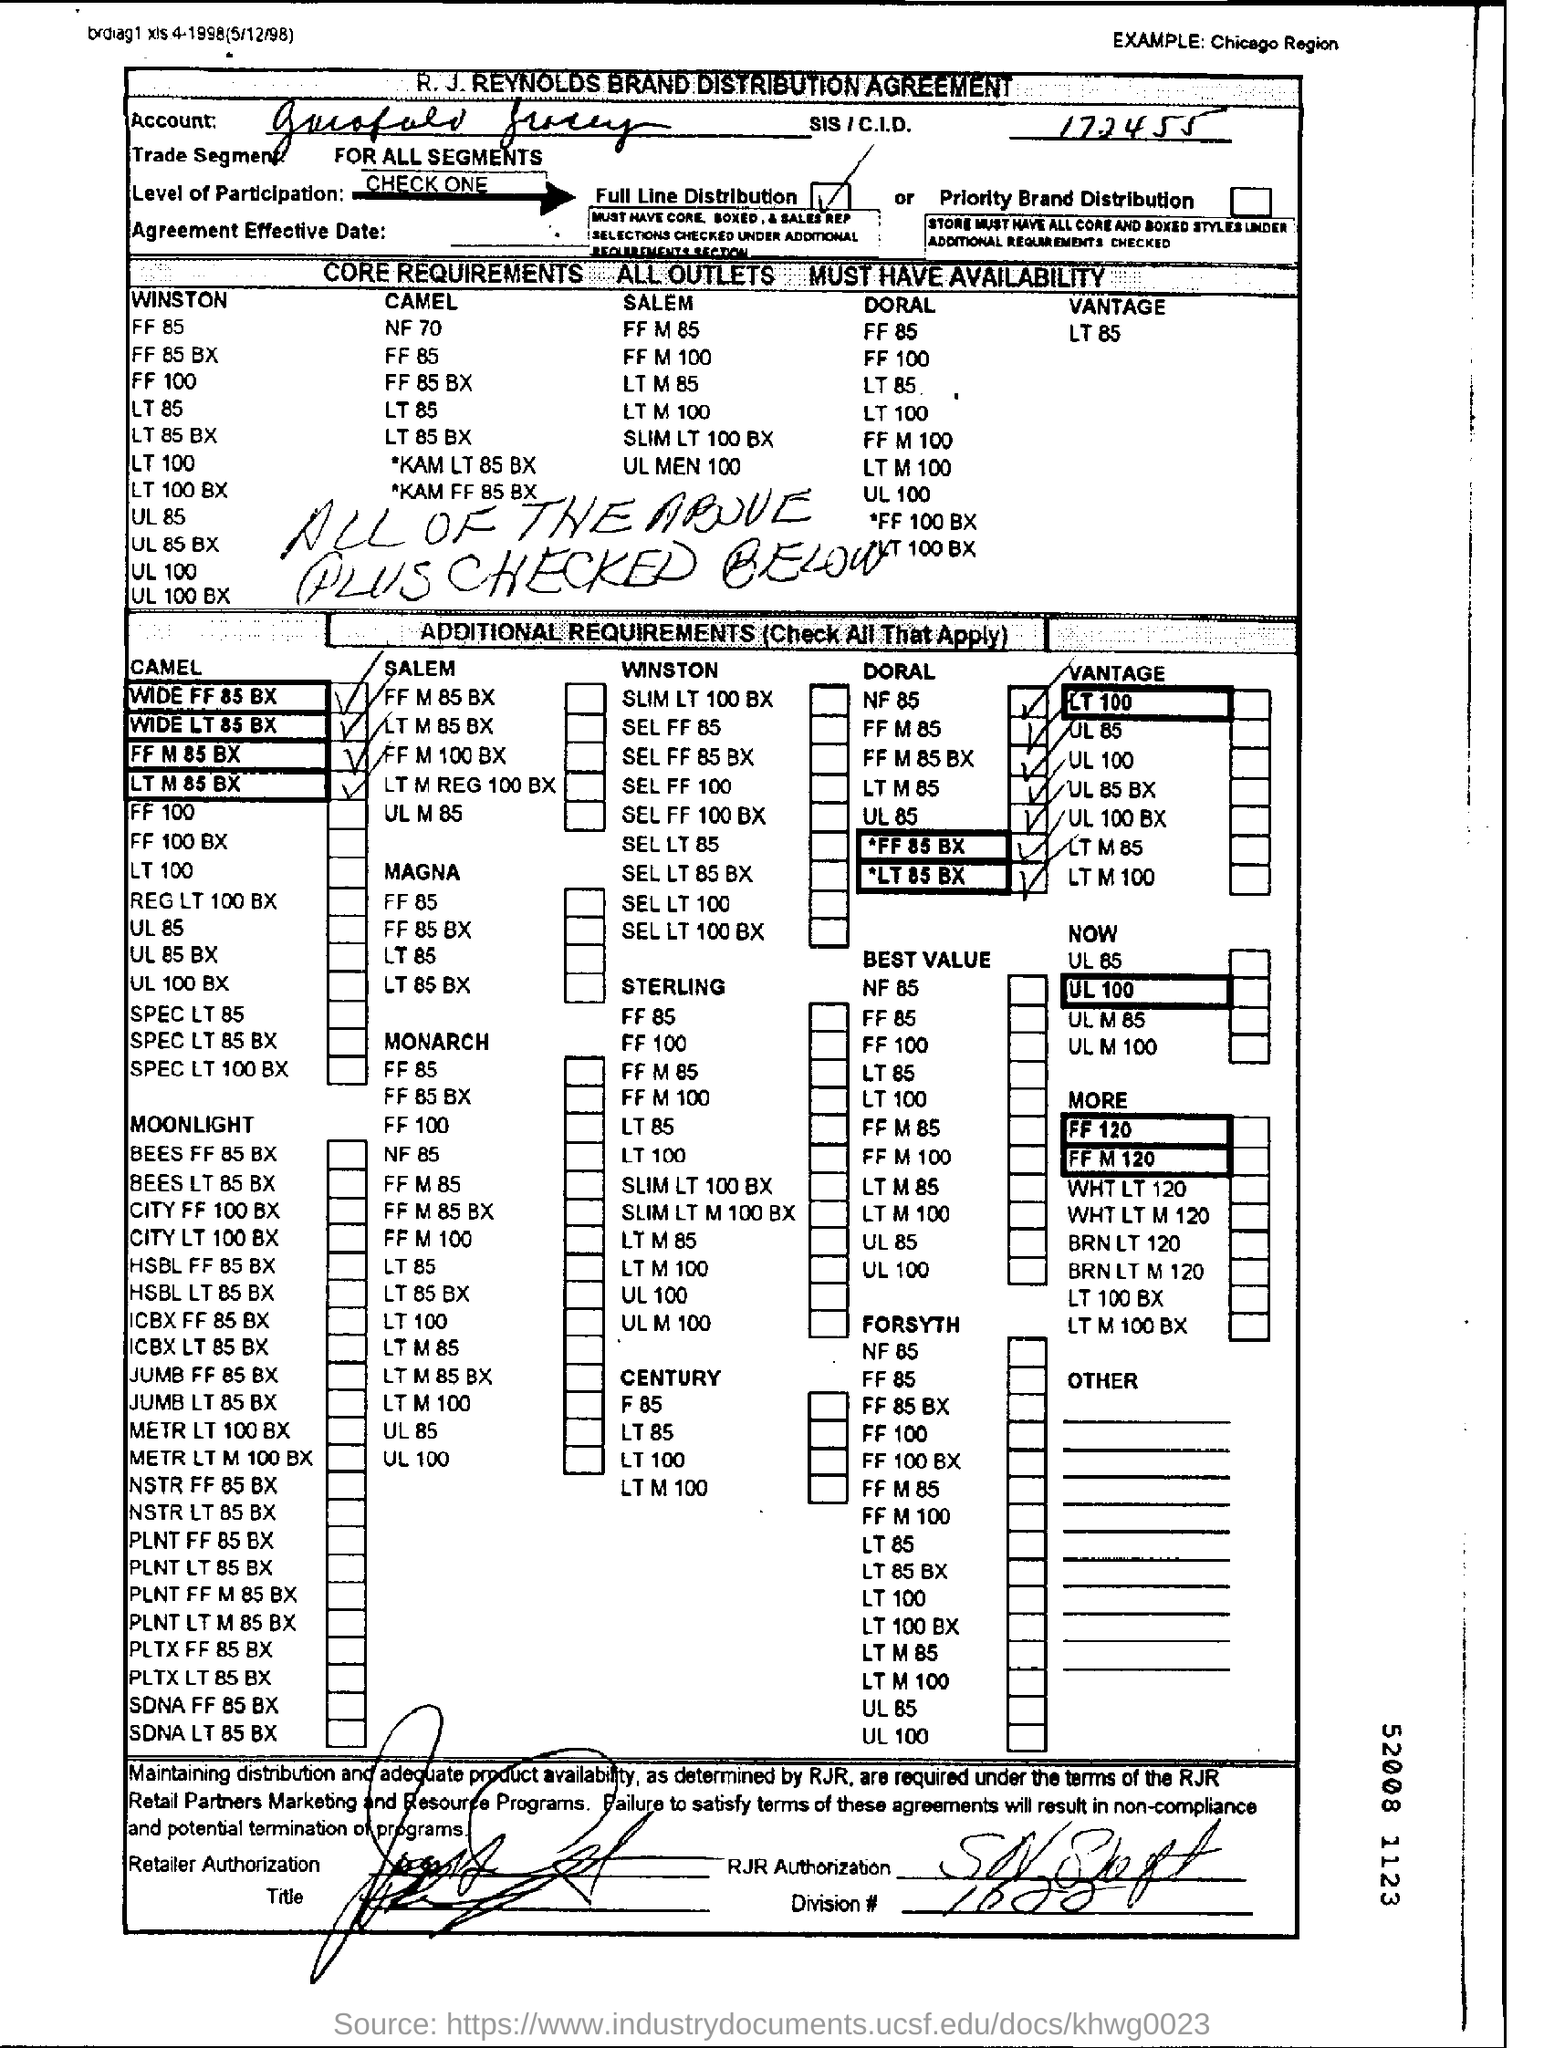What is the text wtitten on the top right corner?
Offer a terse response. EXAMPLE:Chicago Region. What is the name of the company on the top of the document ?
Your answer should be very brief. R. J. REYNOLDS BRAND DISTRIBUTION AGREEMENT. 